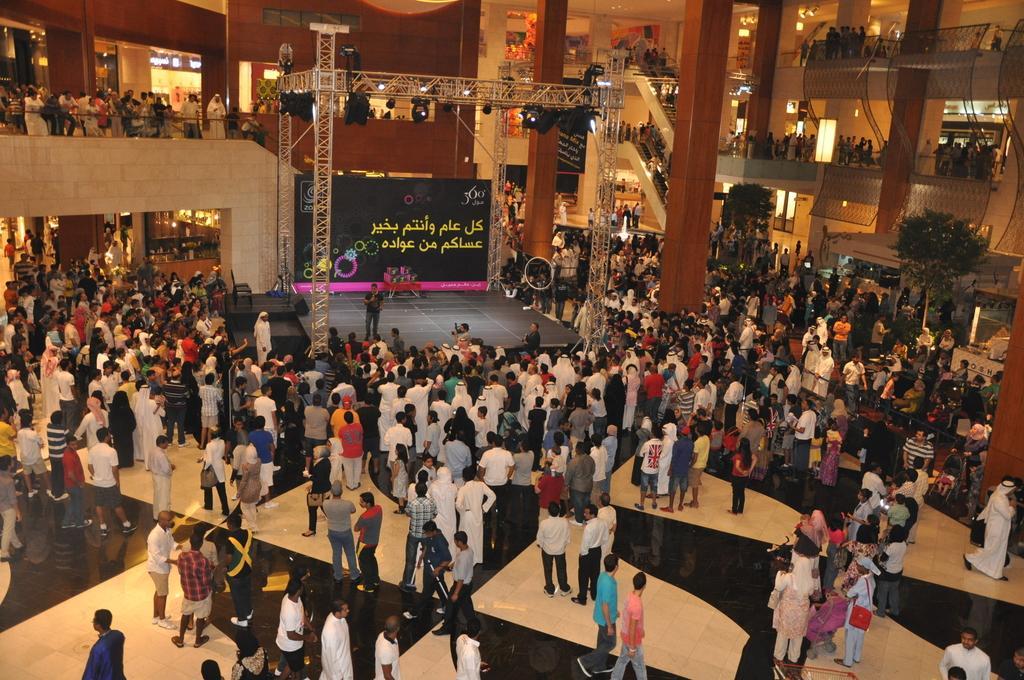How would you summarize this image in a sentence or two? Here in this picture it looks like a mall in which an event is being organized at the centre stage. Many people are watching it. 